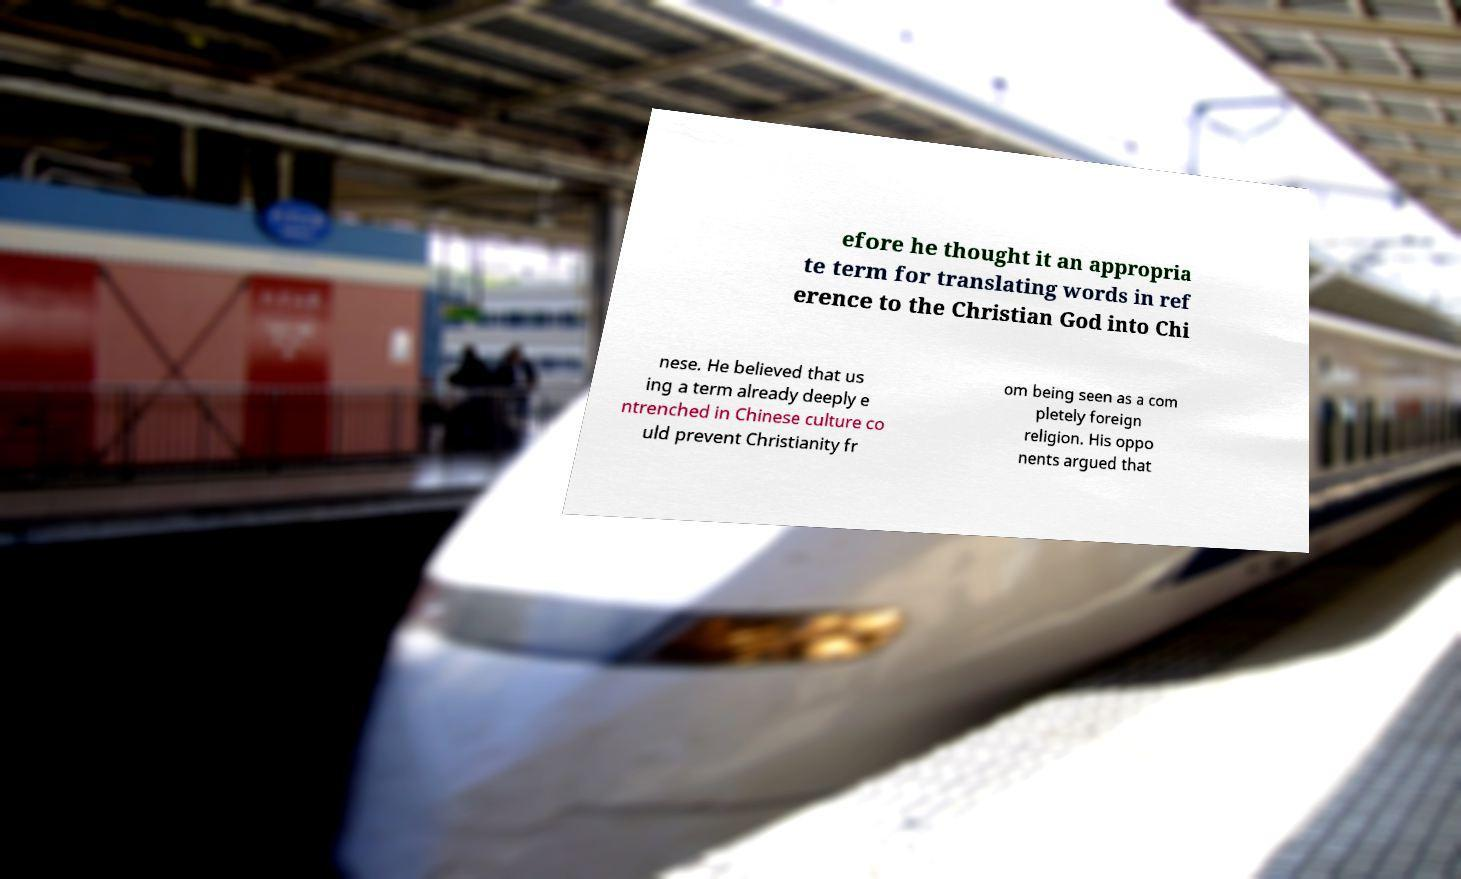What messages or text are displayed in this image? I need them in a readable, typed format. efore he thought it an appropria te term for translating words in ref erence to the Christian God into Chi nese. He believed that us ing a term already deeply e ntrenched in Chinese culture co uld prevent Christianity fr om being seen as a com pletely foreign religion. His oppo nents argued that 